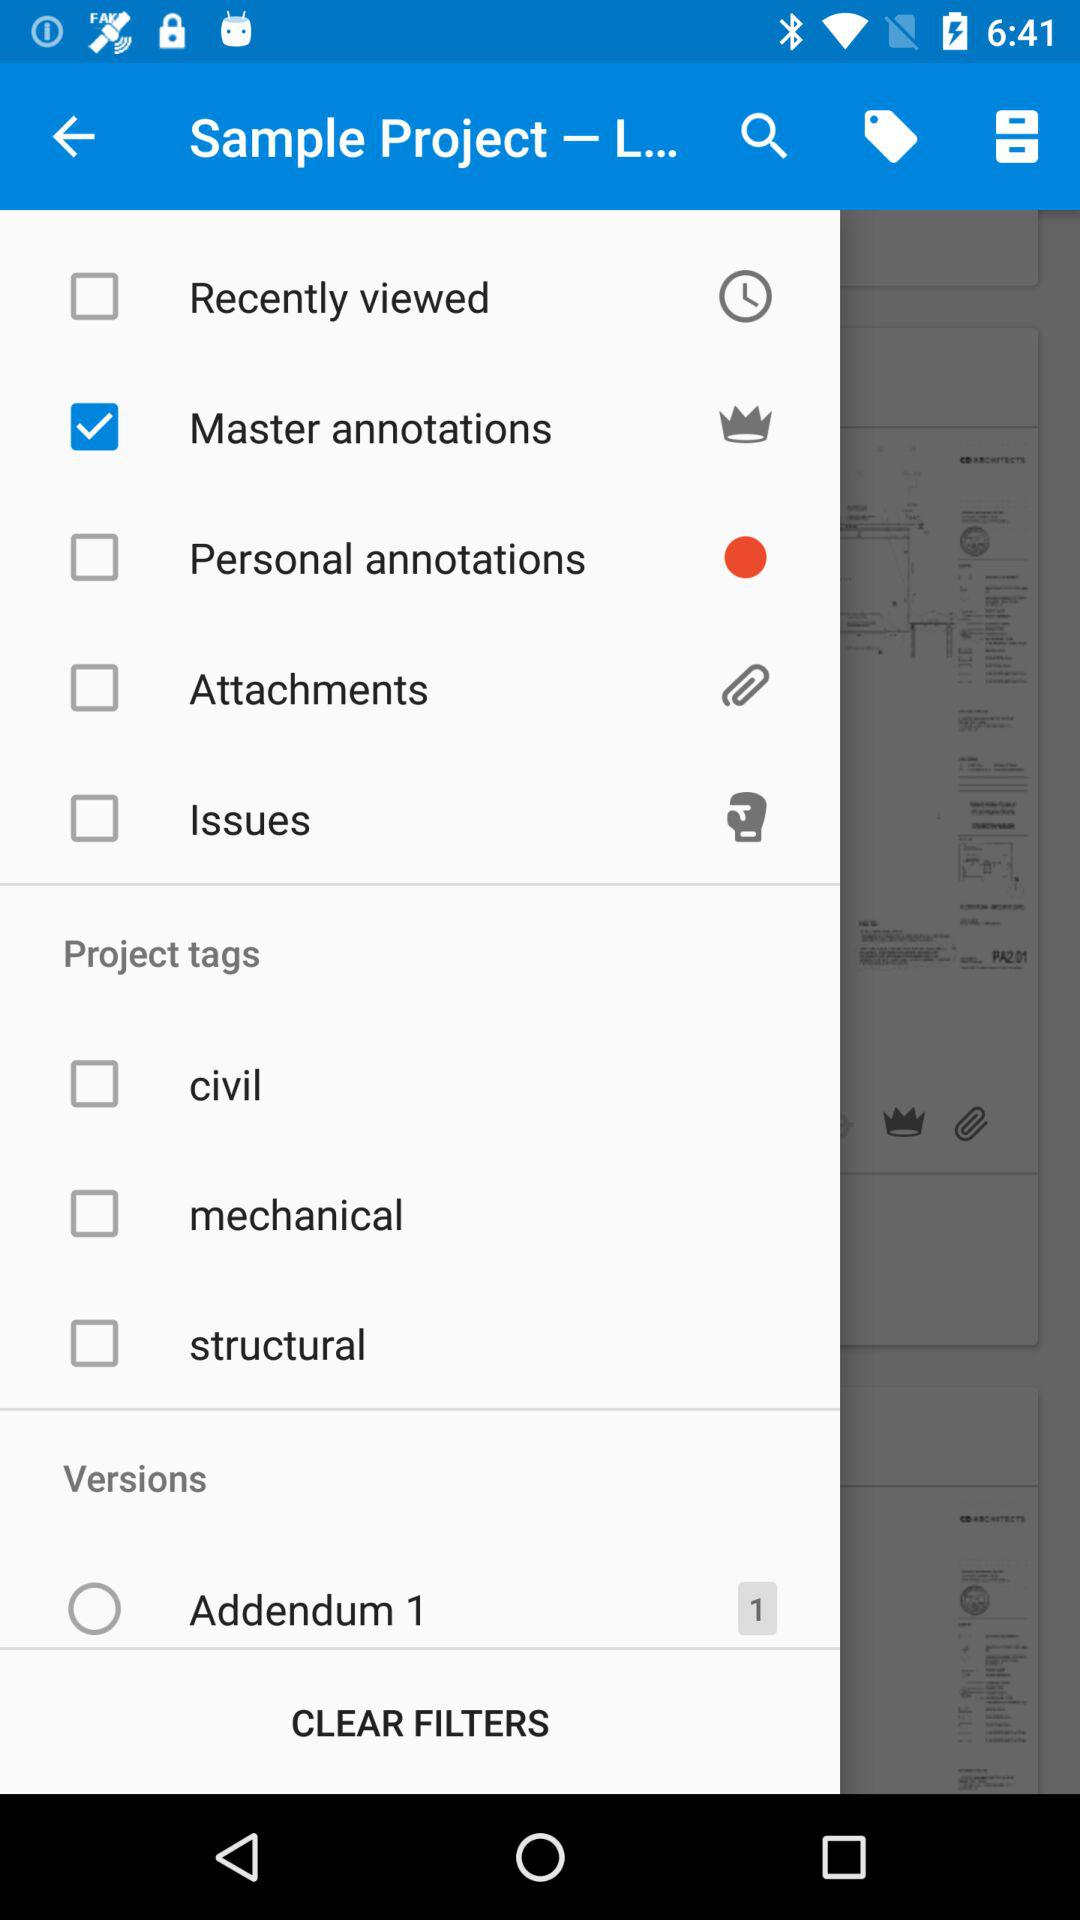What are the categories of project tags? The categories of project tags are "civil", "mechanical" and "structural". 